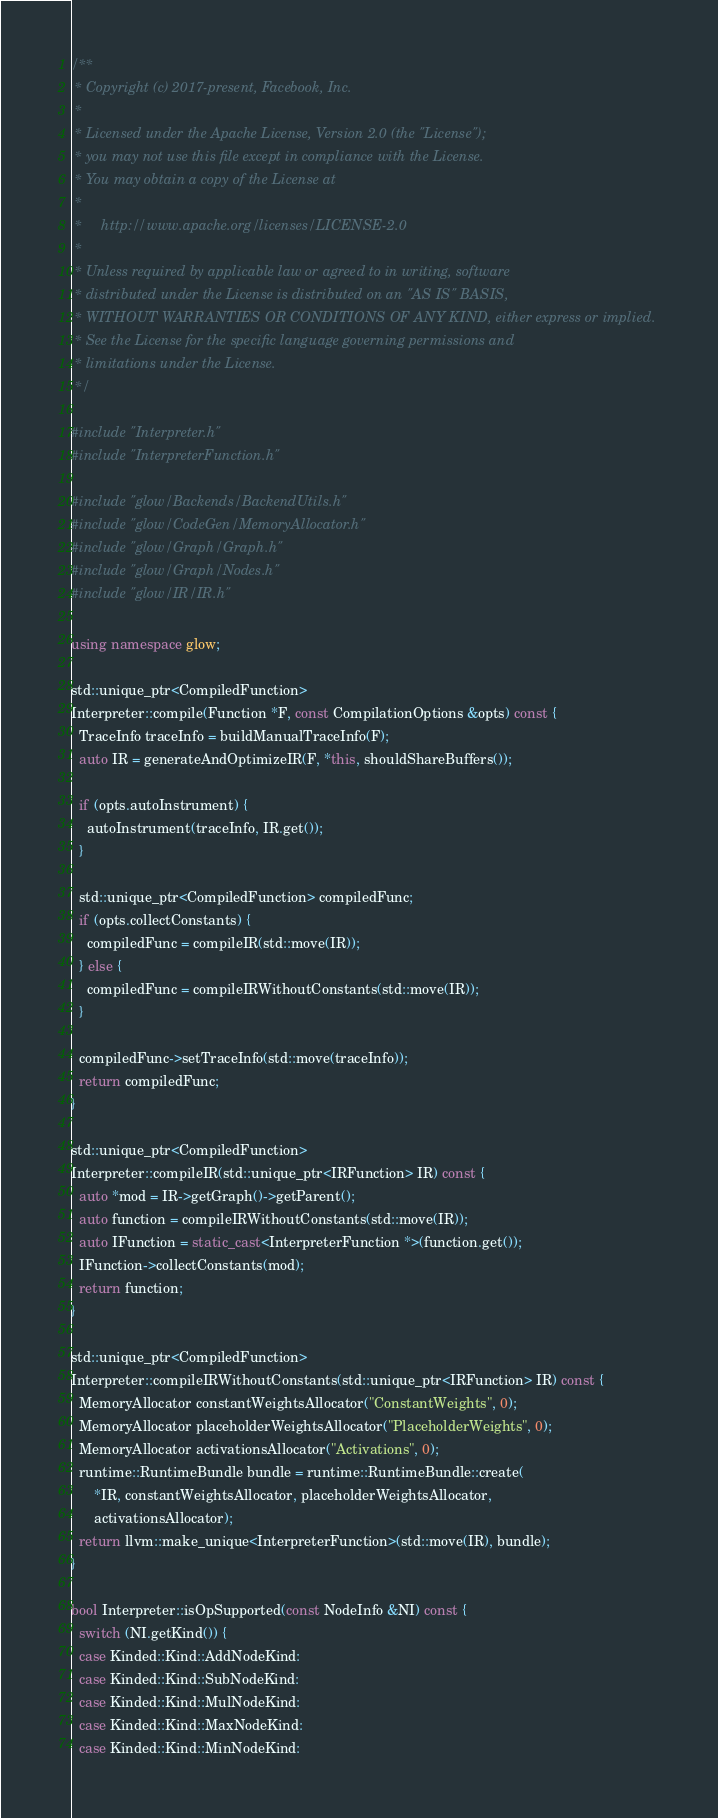<code> <loc_0><loc_0><loc_500><loc_500><_C++_>/**
 * Copyright (c) 2017-present, Facebook, Inc.
 *
 * Licensed under the Apache License, Version 2.0 (the "License");
 * you may not use this file except in compliance with the License.
 * You may obtain a copy of the License at
 *
 *     http://www.apache.org/licenses/LICENSE-2.0
 *
 * Unless required by applicable law or agreed to in writing, software
 * distributed under the License is distributed on an "AS IS" BASIS,
 * WITHOUT WARRANTIES OR CONDITIONS OF ANY KIND, either express or implied.
 * See the License for the specific language governing permissions and
 * limitations under the License.
 */

#include "Interpreter.h"
#include "InterpreterFunction.h"

#include "glow/Backends/BackendUtils.h"
#include "glow/CodeGen/MemoryAllocator.h"
#include "glow/Graph/Graph.h"
#include "glow/Graph/Nodes.h"
#include "glow/IR/IR.h"

using namespace glow;

std::unique_ptr<CompiledFunction>
Interpreter::compile(Function *F, const CompilationOptions &opts) const {
  TraceInfo traceInfo = buildManualTraceInfo(F);
  auto IR = generateAndOptimizeIR(F, *this, shouldShareBuffers());

  if (opts.autoInstrument) {
    autoInstrument(traceInfo, IR.get());
  }

  std::unique_ptr<CompiledFunction> compiledFunc;
  if (opts.collectConstants) {
    compiledFunc = compileIR(std::move(IR));
  } else {
    compiledFunc = compileIRWithoutConstants(std::move(IR));
  }

  compiledFunc->setTraceInfo(std::move(traceInfo));
  return compiledFunc;
}

std::unique_ptr<CompiledFunction>
Interpreter::compileIR(std::unique_ptr<IRFunction> IR) const {
  auto *mod = IR->getGraph()->getParent();
  auto function = compileIRWithoutConstants(std::move(IR));
  auto IFunction = static_cast<InterpreterFunction *>(function.get());
  IFunction->collectConstants(mod);
  return function;
}

std::unique_ptr<CompiledFunction>
Interpreter::compileIRWithoutConstants(std::unique_ptr<IRFunction> IR) const {
  MemoryAllocator constantWeightsAllocator("ConstantWeights", 0);
  MemoryAllocator placeholderWeightsAllocator("PlaceholderWeights", 0);
  MemoryAllocator activationsAllocator("Activations", 0);
  runtime::RuntimeBundle bundle = runtime::RuntimeBundle::create(
      *IR, constantWeightsAllocator, placeholderWeightsAllocator,
      activationsAllocator);
  return llvm::make_unique<InterpreterFunction>(std::move(IR), bundle);
}

bool Interpreter::isOpSupported(const NodeInfo &NI) const {
  switch (NI.getKind()) {
  case Kinded::Kind::AddNodeKind:
  case Kinded::Kind::SubNodeKind:
  case Kinded::Kind::MulNodeKind:
  case Kinded::Kind::MaxNodeKind:
  case Kinded::Kind::MinNodeKind:</code> 